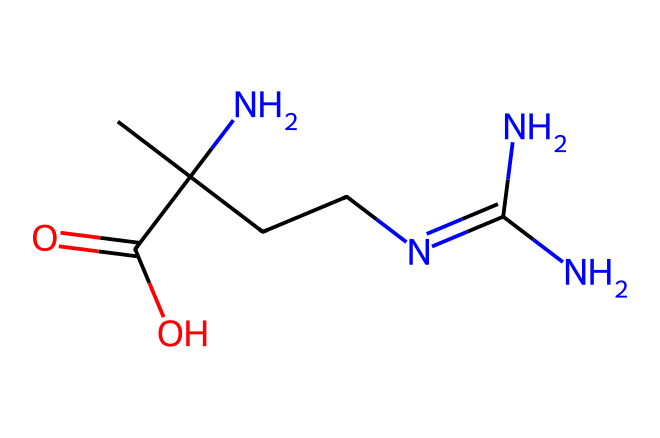What is the functional group present in creatine? The chemical structure features an amine group (NH2), which is characteristic of amino compounds. This is seen in the presence of the nitrogen atoms bonded to hydrogen, indicating basic properties typical of amines.
Answer: amine How many carbon atoms are in creatine? By analyzing the structure, we can count the carbon (C) atoms shown in the chemical, which gives us a total of 4 carbon atoms in the SMILES representation.
Answer: 4 What is the total number of nitrogen atoms in creatine? In the SMILES representation, we see that there are 3 nitrogen (N) atoms present, indicated explicitly by the notation 'N' in different parts of the structure.
Answer: 3 Does creatine contain any carboxyl functional groups? Upon examining the structure, we find there is a carboxylic acid (-COOH) group, which indicates the presence of a carboxylate or carboxylic acid functional group. This can be identified by the carbon atom double bonded to an oxygen and single bonded to a hydroxyl group.
Answer: yes Is creatine a natural or synthetic compound? Generally, creatine is naturally produced in the human body and can also be obtained from dietary sources such as meat. The structure does not indicate synthetic characteristics.
Answer: natural What type of chemical compound is creatine classified as? Creatine is classified as a non-proteinogenic amino acid as it is involved in energy metabolism but not utilized directly for protein synthesis like standard amino acids.
Answer: non-proteinogenic amino acid 